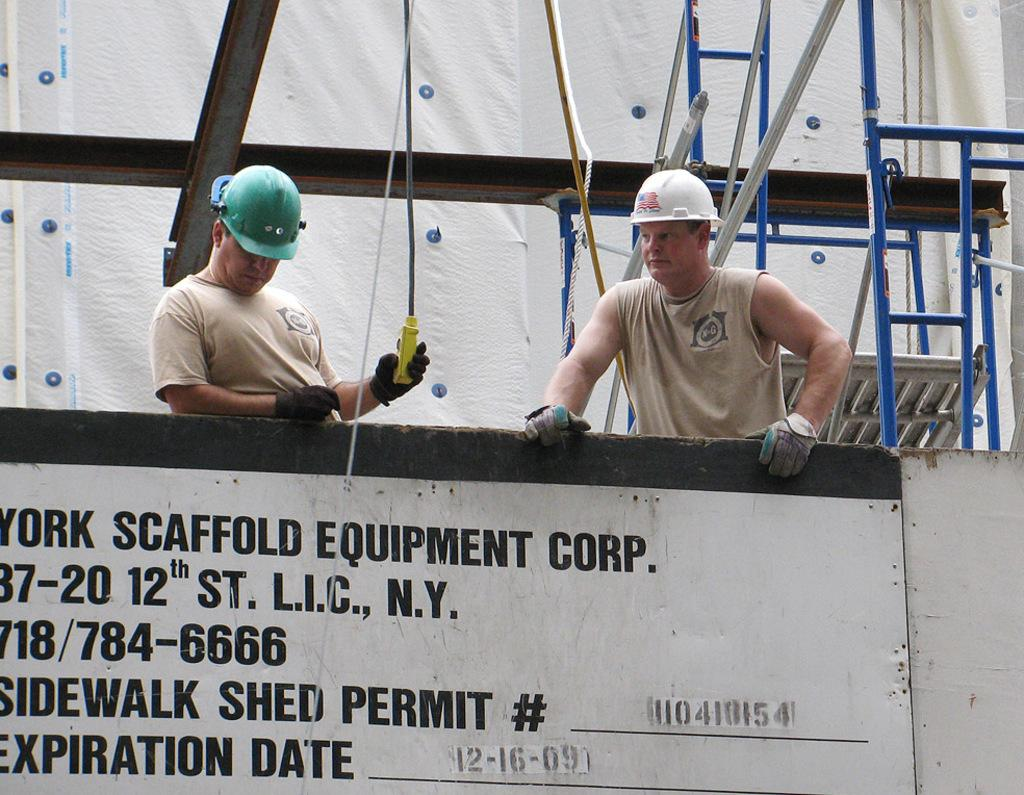How many people are present in the image? There are two men standing in the image. What can be seen in the background of the image? There is an advertisement board in the image. What object is present that could be used for tying or securing? There is a rope in the image. What color is the cork in the image? There is no cork present in the image. How is the fuel being used in the image? There is no fuel present in the image. 